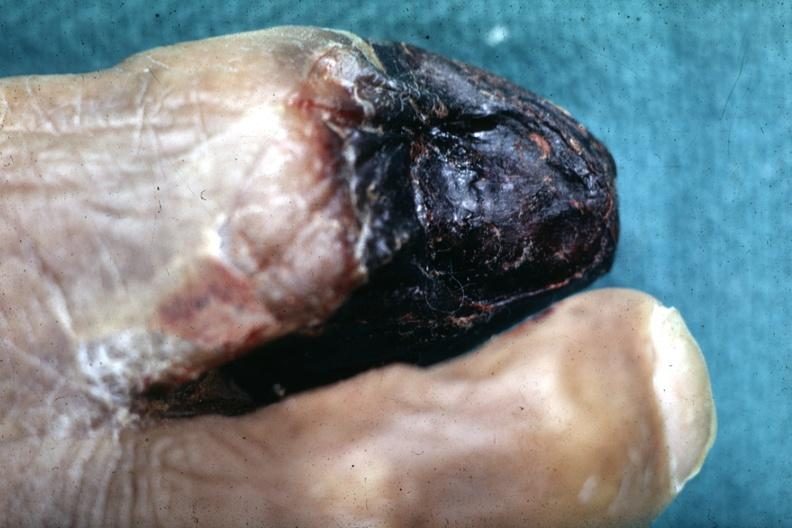what does this image show?
Answer the question using a single word or phrase. Close-up view of gangrene 